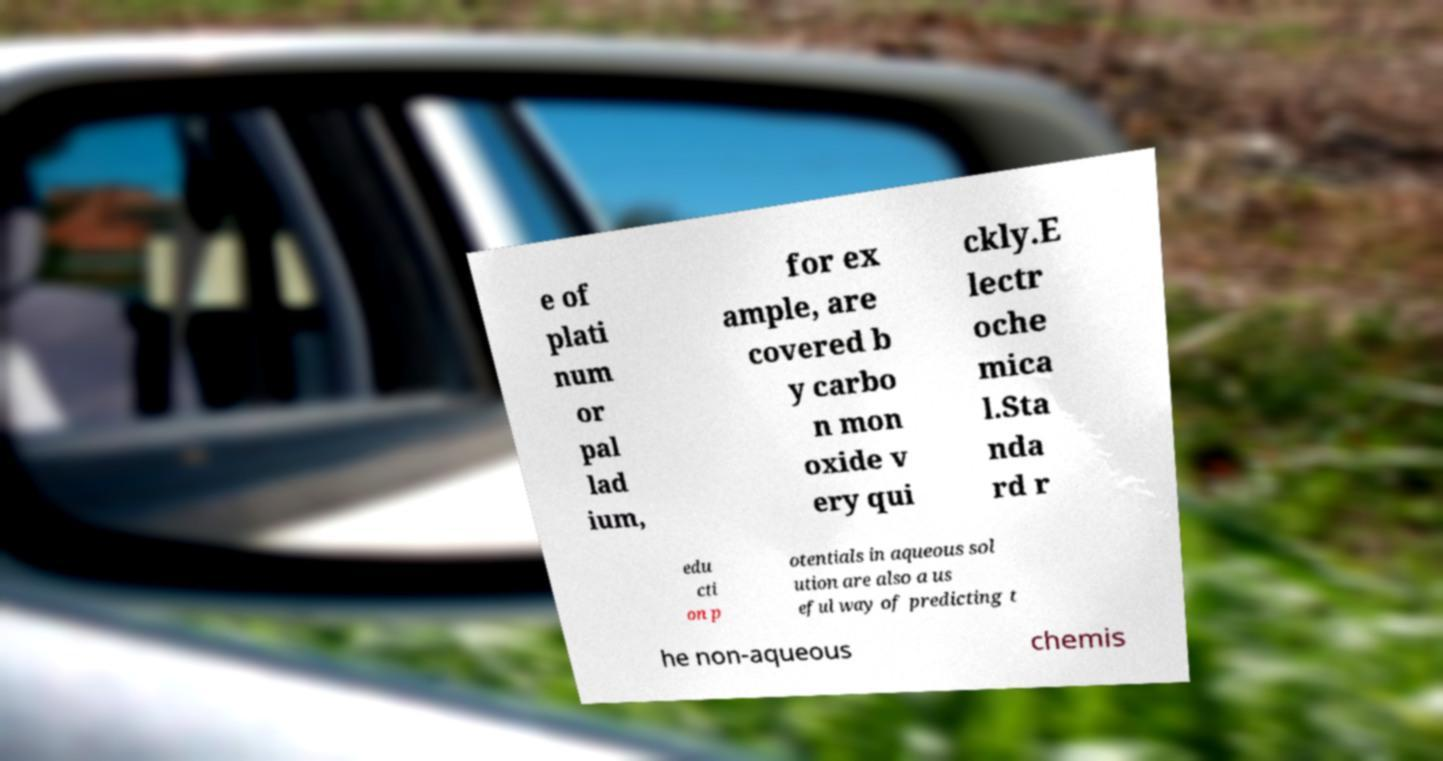Could you extract and type out the text from this image? e of plati num or pal lad ium, for ex ample, are covered b y carbo n mon oxide v ery qui ckly.E lectr oche mica l.Sta nda rd r edu cti on p otentials in aqueous sol ution are also a us eful way of predicting t he non-aqueous chemis 